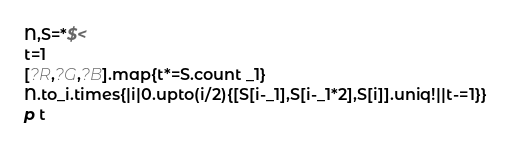Convert code to text. <code><loc_0><loc_0><loc_500><loc_500><_Ruby_>N,S=*$<
t=1
[?R,?G,?B].map{t*=S.count _1}
N.to_i.times{|i|0.upto(i/2){[S[i-_1],S[i-_1*2],S[i]].uniq!||t-=1}}
p t</code> 